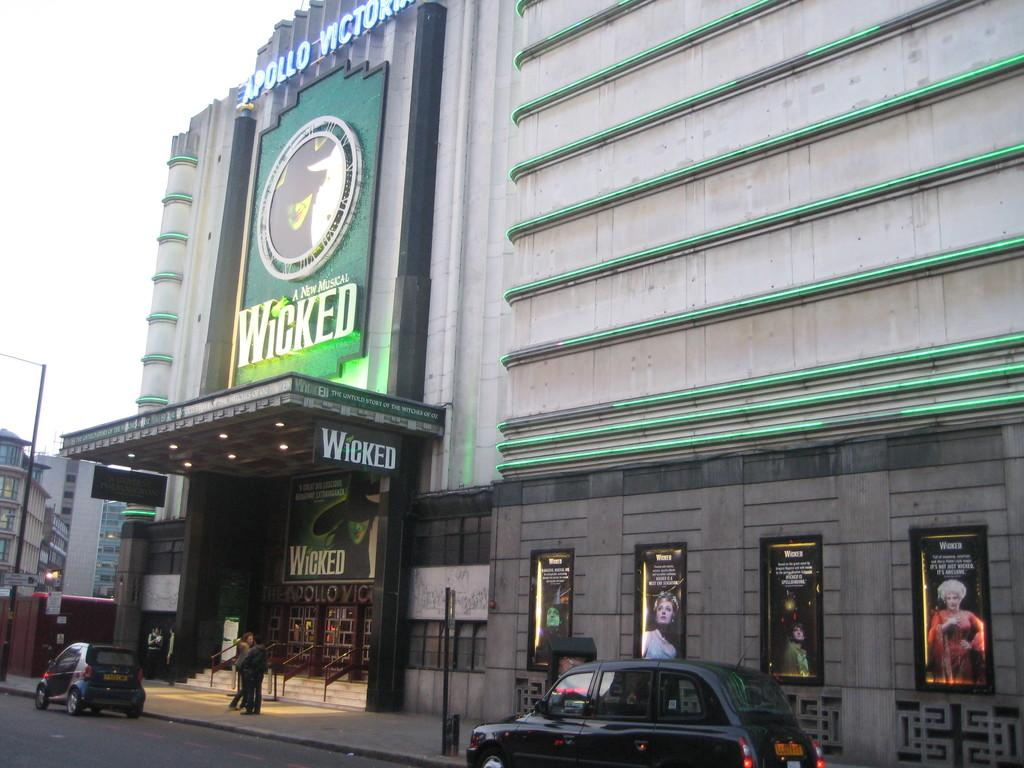<image>
Offer a succinct explanation of the picture presented. an ad for the play Wicked on a building 